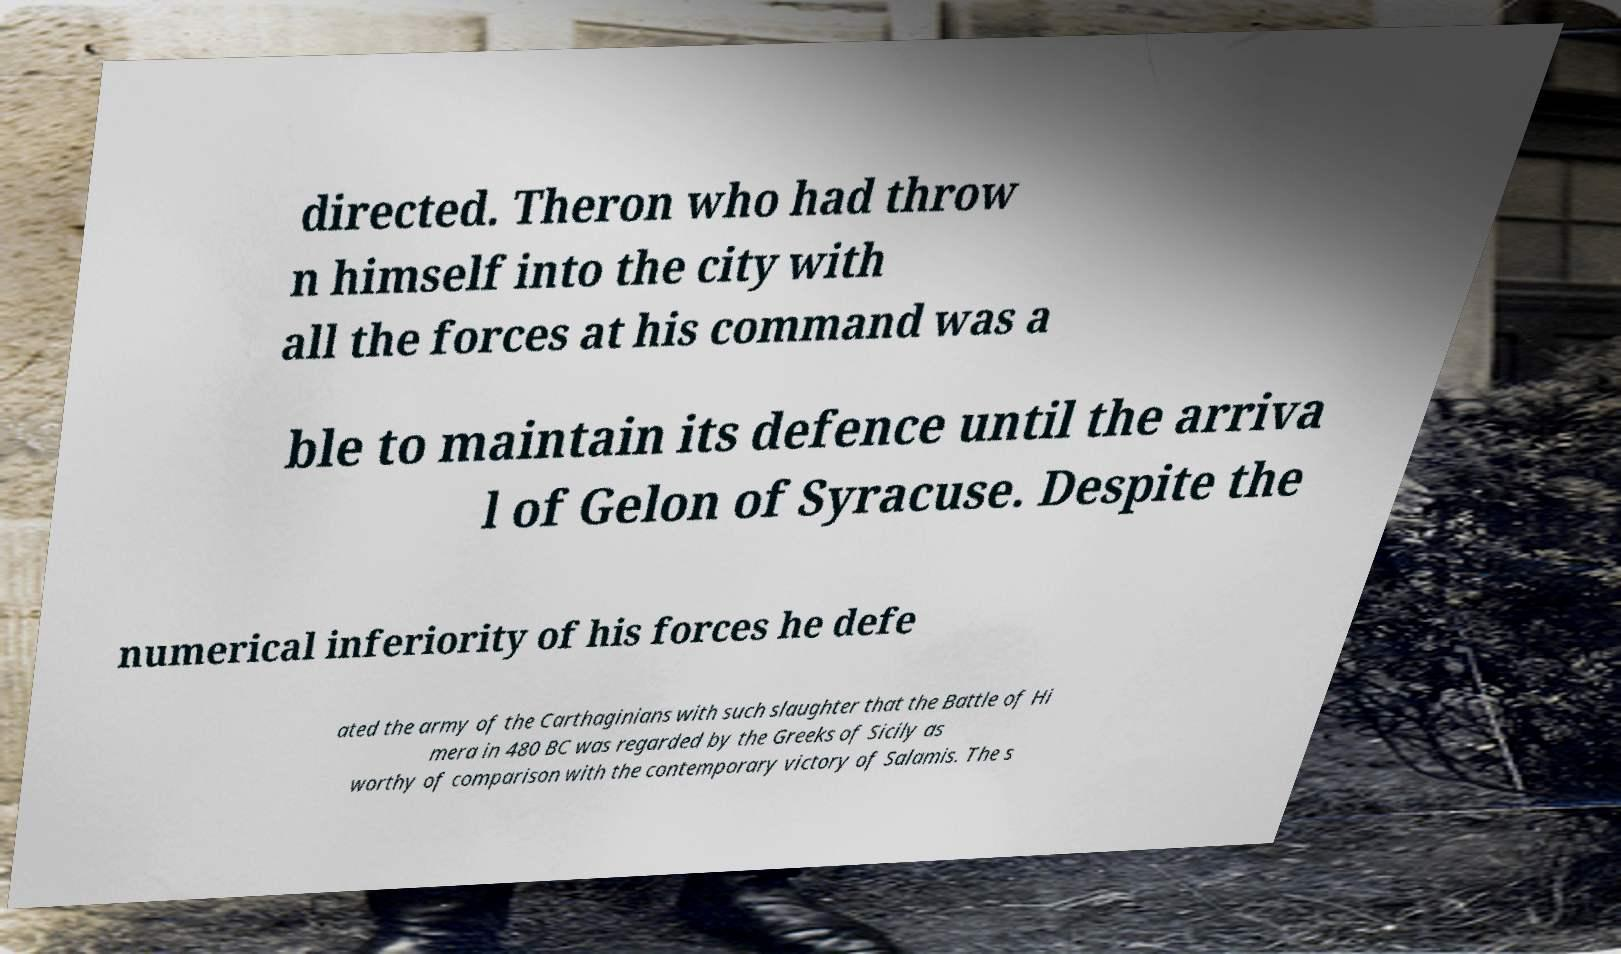There's text embedded in this image that I need extracted. Can you transcribe it verbatim? directed. Theron who had throw n himself into the city with all the forces at his command was a ble to maintain its defence until the arriva l of Gelon of Syracuse. Despite the numerical inferiority of his forces he defe ated the army of the Carthaginians with such slaughter that the Battle of Hi mera in 480 BC was regarded by the Greeks of Sicily as worthy of comparison with the contemporary victory of Salamis. The s 